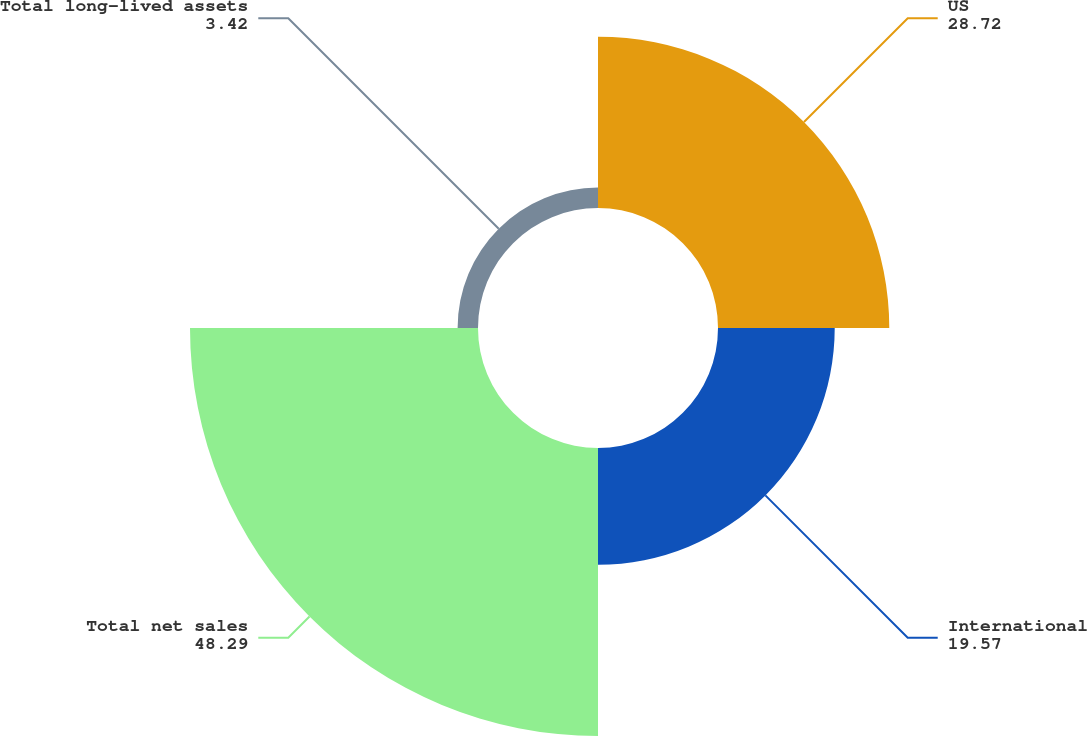Convert chart to OTSL. <chart><loc_0><loc_0><loc_500><loc_500><pie_chart><fcel>US<fcel>International<fcel>Total net sales<fcel>Total long-lived assets<nl><fcel>28.72%<fcel>19.57%<fcel>48.29%<fcel>3.42%<nl></chart> 